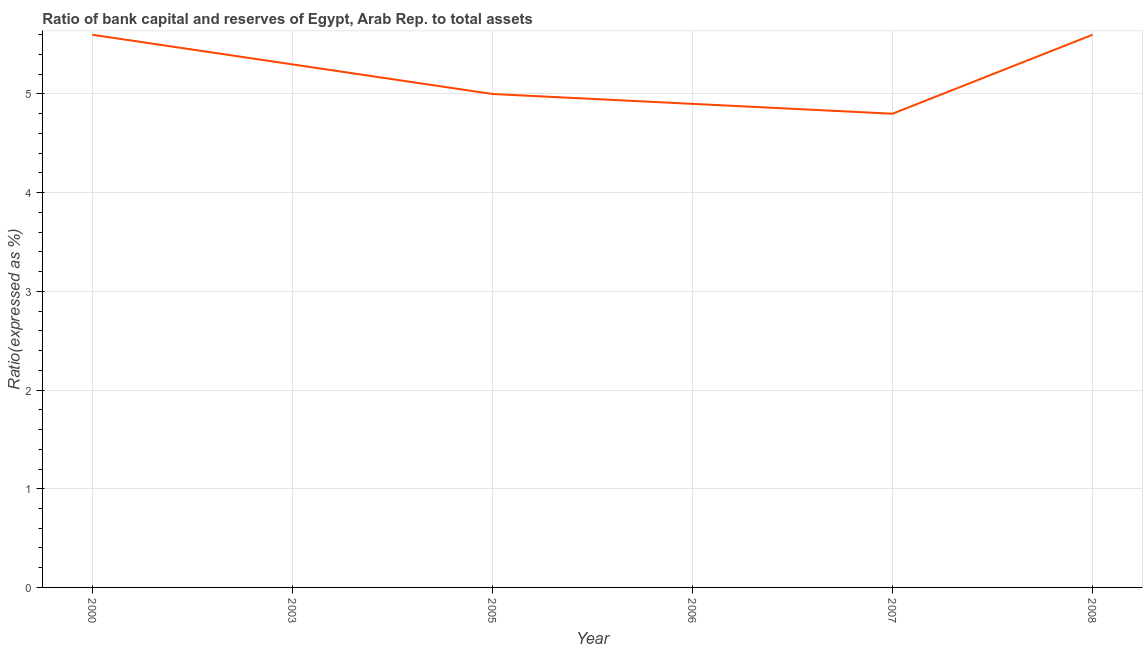What is the bank capital to assets ratio in 2008?
Your response must be concise. 5.6. Across all years, what is the minimum bank capital to assets ratio?
Your answer should be compact. 4.8. In which year was the bank capital to assets ratio minimum?
Provide a succinct answer. 2007. What is the sum of the bank capital to assets ratio?
Offer a terse response. 31.2. What is the difference between the bank capital to assets ratio in 2000 and 2003?
Your response must be concise. 0.3. What is the average bank capital to assets ratio per year?
Offer a very short reply. 5.2. What is the median bank capital to assets ratio?
Provide a succinct answer. 5.15. In how many years, is the bank capital to assets ratio greater than 3.4 %?
Offer a terse response. 6. What is the difference between the highest and the second highest bank capital to assets ratio?
Your answer should be compact. 0. Is the sum of the bank capital to assets ratio in 2003 and 2007 greater than the maximum bank capital to assets ratio across all years?
Offer a very short reply. Yes. What is the difference between the highest and the lowest bank capital to assets ratio?
Give a very brief answer. 0.8. In how many years, is the bank capital to assets ratio greater than the average bank capital to assets ratio taken over all years?
Provide a succinct answer. 3. How many years are there in the graph?
Your answer should be very brief. 6. Are the values on the major ticks of Y-axis written in scientific E-notation?
Offer a terse response. No. What is the title of the graph?
Your answer should be very brief. Ratio of bank capital and reserves of Egypt, Arab Rep. to total assets. What is the label or title of the X-axis?
Provide a succinct answer. Year. What is the label or title of the Y-axis?
Ensure brevity in your answer.  Ratio(expressed as %). What is the Ratio(expressed as %) in 2000?
Your answer should be compact. 5.6. What is the Ratio(expressed as %) of 2007?
Your answer should be compact. 4.8. What is the difference between the Ratio(expressed as %) in 2000 and 2005?
Provide a short and direct response. 0.6. What is the difference between the Ratio(expressed as %) in 2000 and 2006?
Offer a very short reply. 0.7. What is the difference between the Ratio(expressed as %) in 2000 and 2007?
Keep it short and to the point. 0.8. What is the difference between the Ratio(expressed as %) in 2003 and 2005?
Ensure brevity in your answer.  0.3. What is the difference between the Ratio(expressed as %) in 2003 and 2006?
Offer a very short reply. 0.4. What is the difference between the Ratio(expressed as %) in 2005 and 2007?
Offer a very short reply. 0.2. What is the difference between the Ratio(expressed as %) in 2006 and 2008?
Offer a terse response. -0.7. What is the difference between the Ratio(expressed as %) in 2007 and 2008?
Give a very brief answer. -0.8. What is the ratio of the Ratio(expressed as %) in 2000 to that in 2003?
Provide a succinct answer. 1.06. What is the ratio of the Ratio(expressed as %) in 2000 to that in 2005?
Keep it short and to the point. 1.12. What is the ratio of the Ratio(expressed as %) in 2000 to that in 2006?
Your answer should be very brief. 1.14. What is the ratio of the Ratio(expressed as %) in 2000 to that in 2007?
Provide a succinct answer. 1.17. What is the ratio of the Ratio(expressed as %) in 2003 to that in 2005?
Make the answer very short. 1.06. What is the ratio of the Ratio(expressed as %) in 2003 to that in 2006?
Offer a very short reply. 1.08. What is the ratio of the Ratio(expressed as %) in 2003 to that in 2007?
Provide a short and direct response. 1.1. What is the ratio of the Ratio(expressed as %) in 2003 to that in 2008?
Provide a succinct answer. 0.95. What is the ratio of the Ratio(expressed as %) in 2005 to that in 2007?
Your answer should be very brief. 1.04. What is the ratio of the Ratio(expressed as %) in 2005 to that in 2008?
Provide a succinct answer. 0.89. What is the ratio of the Ratio(expressed as %) in 2007 to that in 2008?
Your answer should be compact. 0.86. 